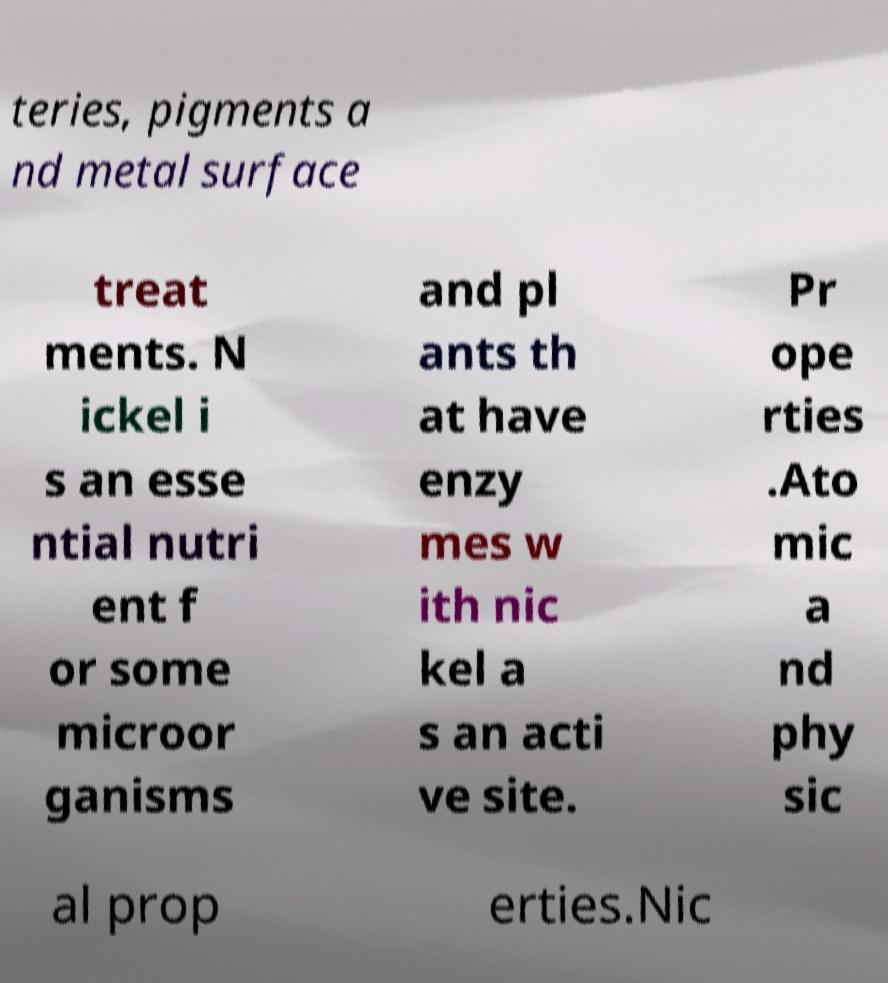What messages or text are displayed in this image? I need them in a readable, typed format. teries, pigments a nd metal surface treat ments. N ickel i s an esse ntial nutri ent f or some microor ganisms and pl ants th at have enzy mes w ith nic kel a s an acti ve site. Pr ope rties .Ato mic a nd phy sic al prop erties.Nic 